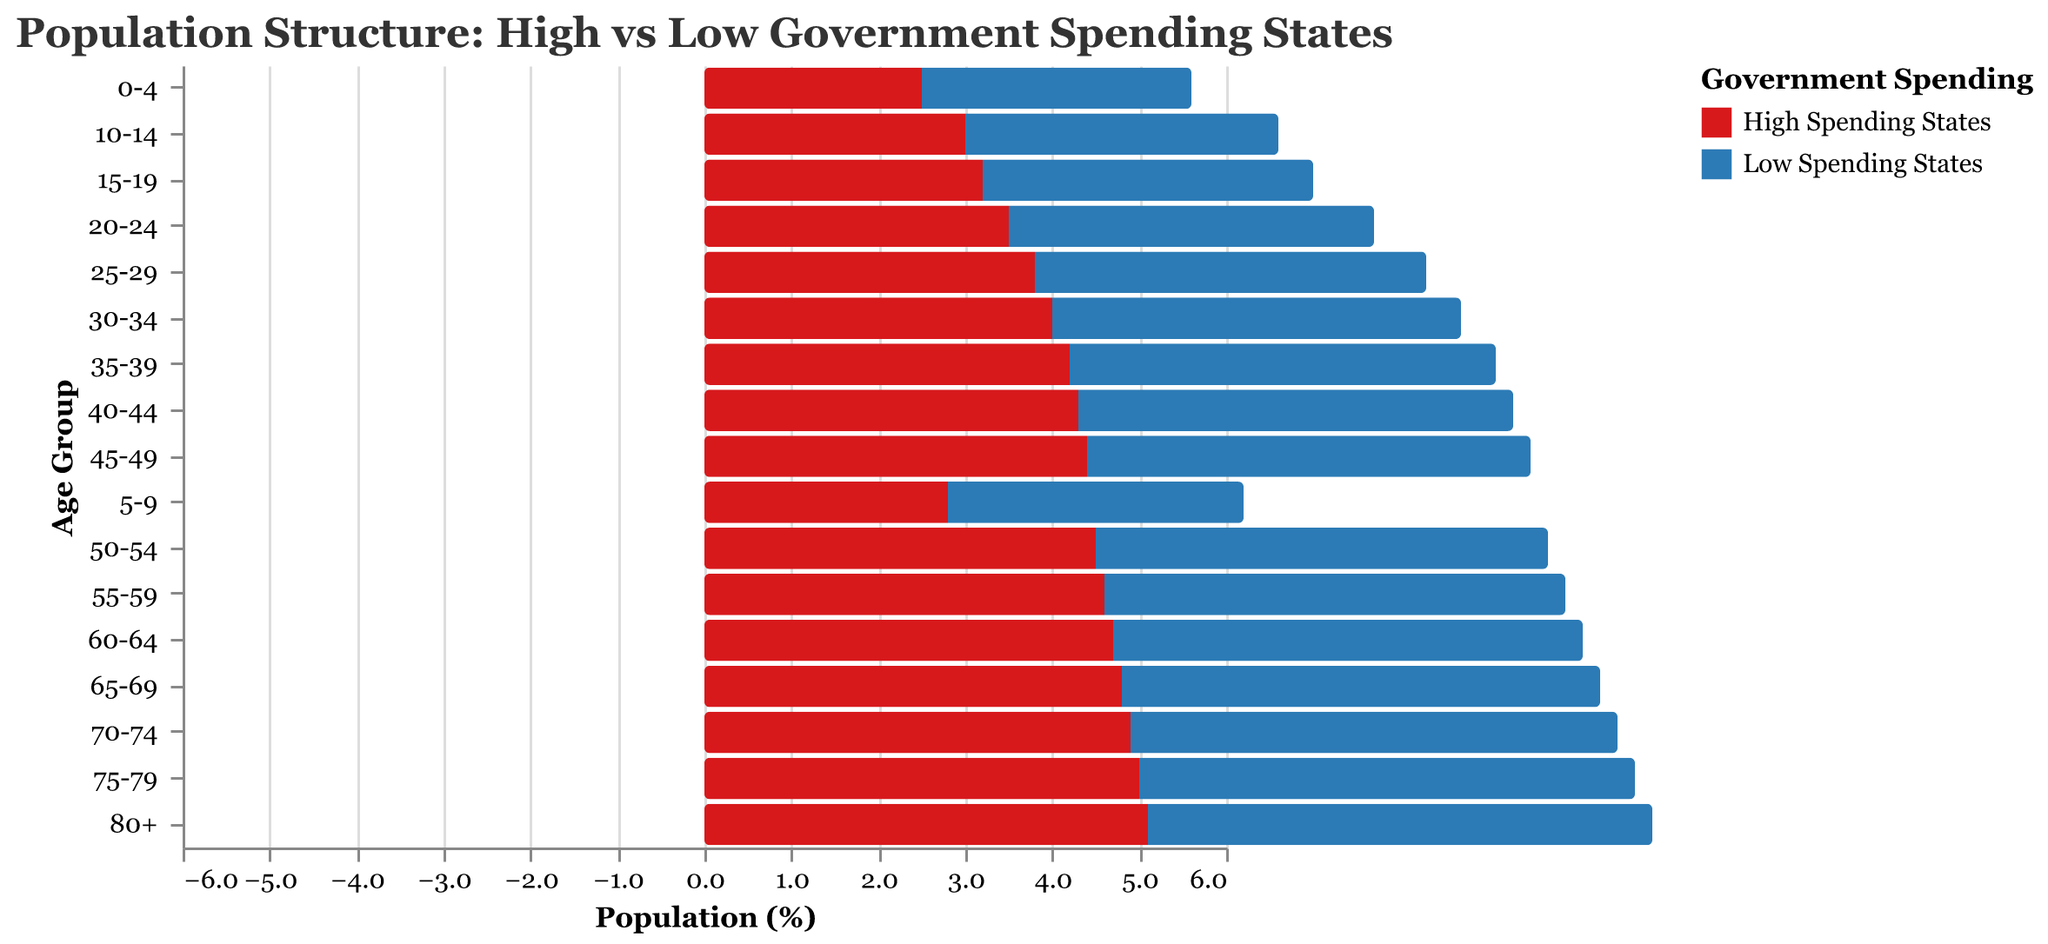What is the title of the plot? The title is written at the top of the figure. It reads "Population Structure: High vs Low Government Spending States".
Answer: Population Structure: High vs Low Government Spending States What is the age group with the highest percentage in Low Spending States? By examining the x-axis on the right side of the chart for the highest bar (most positive value), we see that age group "80+" has the highest percentage at 5.8%.
Answer: 80+ How does the population percentage of age group 25-29 in High Spending States compare to that of Low Spending States? For the age group 25-29, High Spending States have -3.8%, while Low Spending States have 4.5%. The percentage in Low Spending States is higher by 8.3% (4.5% - (-3.8%)).
Answer: Low Spending States have a higher percentage by 8.3% What colors are used to represent High Spending States and Low Spending States, respectively? The color legend on the right indicates that High Spending States are represented in red, while Low Spending States are represented in blue.
Answer: Red for High Spending States, Blue for Low Spending States Which government spending group has a higher percentage in the age group 15-19? In the age group 15-19, High Spending States have -3.2%, and Low Spending States have 3.8%. Low Spending States have a higher percentage by 7% if you sum the absolute values.
Answer: Low Spending States By how much does the population percentage of individuals aged 70-74 differ between High Spending and Low Spending States? In the age group 70-74, High Spending States have -4.9%, and Low Spending States have 5.6%. The difference is 10.5% (5.6% - (-4.9%)).
Answer: 10.5% What general trend can be observed in the population percentages across all age groups for both High Spending and Low Spending States? Observing the entire plot, it is clear that the population percentages decrease steadily in High Spending States as age increases, while they increase steadily in Low Spending States. This suggests an inversely proportional trend.
Answer: Inversely proportional trend For the age group 50-54, calculate the total percentage of the population by summing the absolute values for both High Spending and Low Spending States. The age group 50-54 has -4.5% in High Spending States and 5.2% in Low Spending States. Summing the absolute values: 4.5% + 5.2% = 9.7%.
Answer: 9.7% What is the smallest population percentage in High Spending States, and for which age group does it occur? The smallest population percentage in High Spending States is -5.1%, which occurs in the 80+ age group, as indicated in the data.
Answer: -5.1% in the 80+ age group 